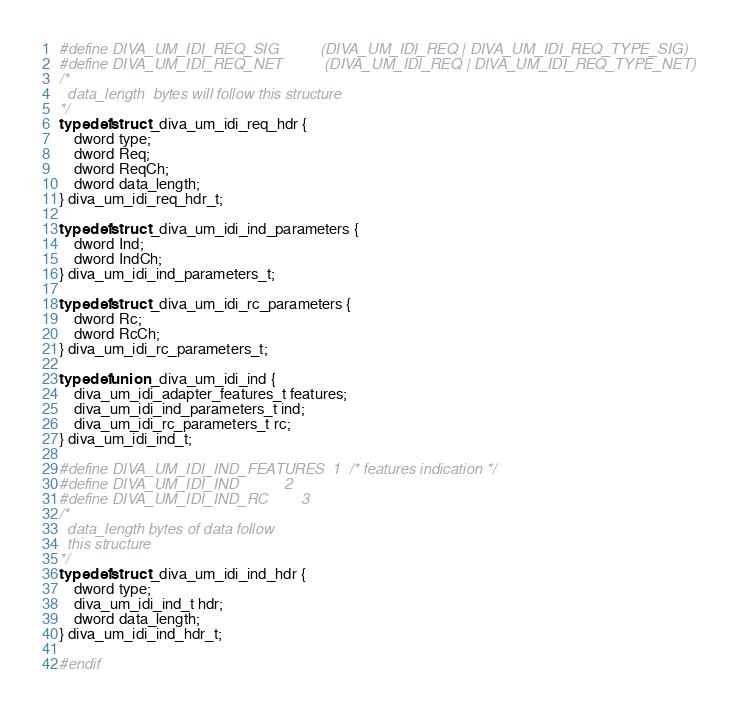<code> <loc_0><loc_0><loc_500><loc_500><_C_>#define DIVA_UM_IDI_REQ_SIG			(DIVA_UM_IDI_REQ | DIVA_UM_IDI_REQ_TYPE_SIG)
#define DIVA_UM_IDI_REQ_NET			(DIVA_UM_IDI_REQ | DIVA_UM_IDI_REQ_TYPE_NET)
/*
  data_length  bytes will follow this structure
*/
typedef struct _diva_um_idi_req_hdr {
	dword type;
	dword Req;
	dword ReqCh;
	dword data_length;
} diva_um_idi_req_hdr_t;

typedef struct _diva_um_idi_ind_parameters {
	dword Ind;
	dword IndCh;
} diva_um_idi_ind_parameters_t;

typedef struct _diva_um_idi_rc_parameters {
	dword Rc;
	dword RcCh;
} diva_um_idi_rc_parameters_t;

typedef union _diva_um_idi_ind {
	diva_um_idi_adapter_features_t features;
	diva_um_idi_ind_parameters_t ind;
	diva_um_idi_rc_parameters_t rc;
} diva_um_idi_ind_t;

#define DIVA_UM_IDI_IND_FEATURES  1	/* features indication */
#define DIVA_UM_IDI_IND           2
#define DIVA_UM_IDI_IND_RC        3
/*
  data_length bytes of data follow
  this structure
*/
typedef struct _diva_um_idi_ind_hdr {
	dword type;
	diva_um_idi_ind_t hdr;
	dword data_length;
} diva_um_idi_ind_hdr_t;

#endif
</code> 